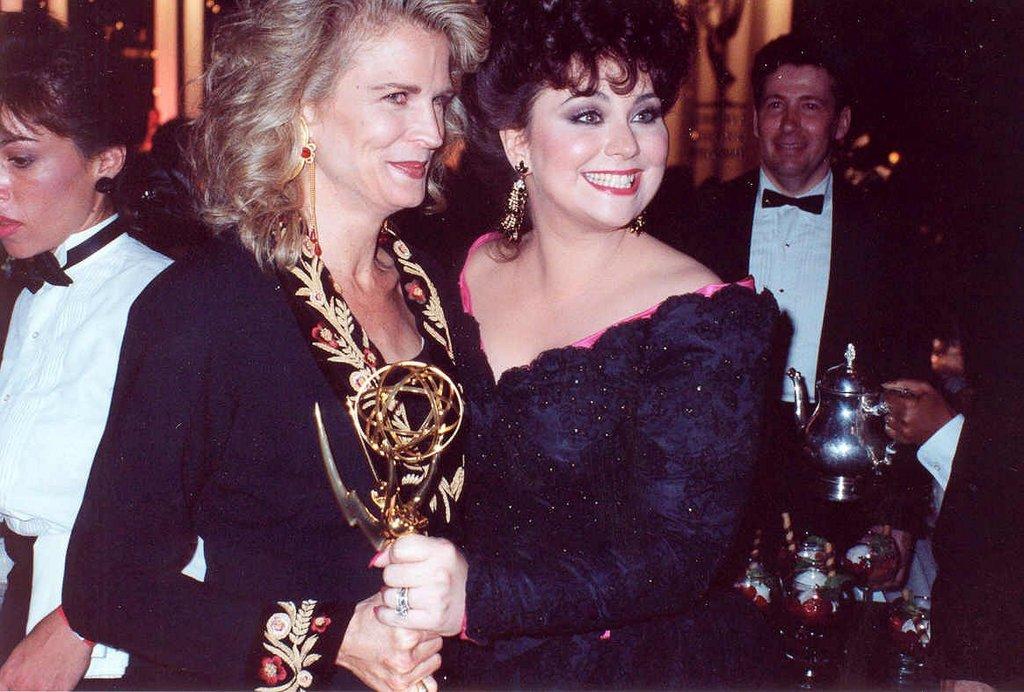Describe this image in one or two sentences. In the image we can see two women standing, wearing clothes, earrings, finger rings and they are smiling, they are holding trophy in their hands. Behind them there are many other people wearing clothes. Here we can see water jug and wine glasses. And the background is dark. 